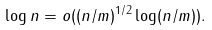<formula> <loc_0><loc_0><loc_500><loc_500>\log n = o ( ( n / m ) ^ { 1 / 2 } \log ( n / m ) ) .</formula> 